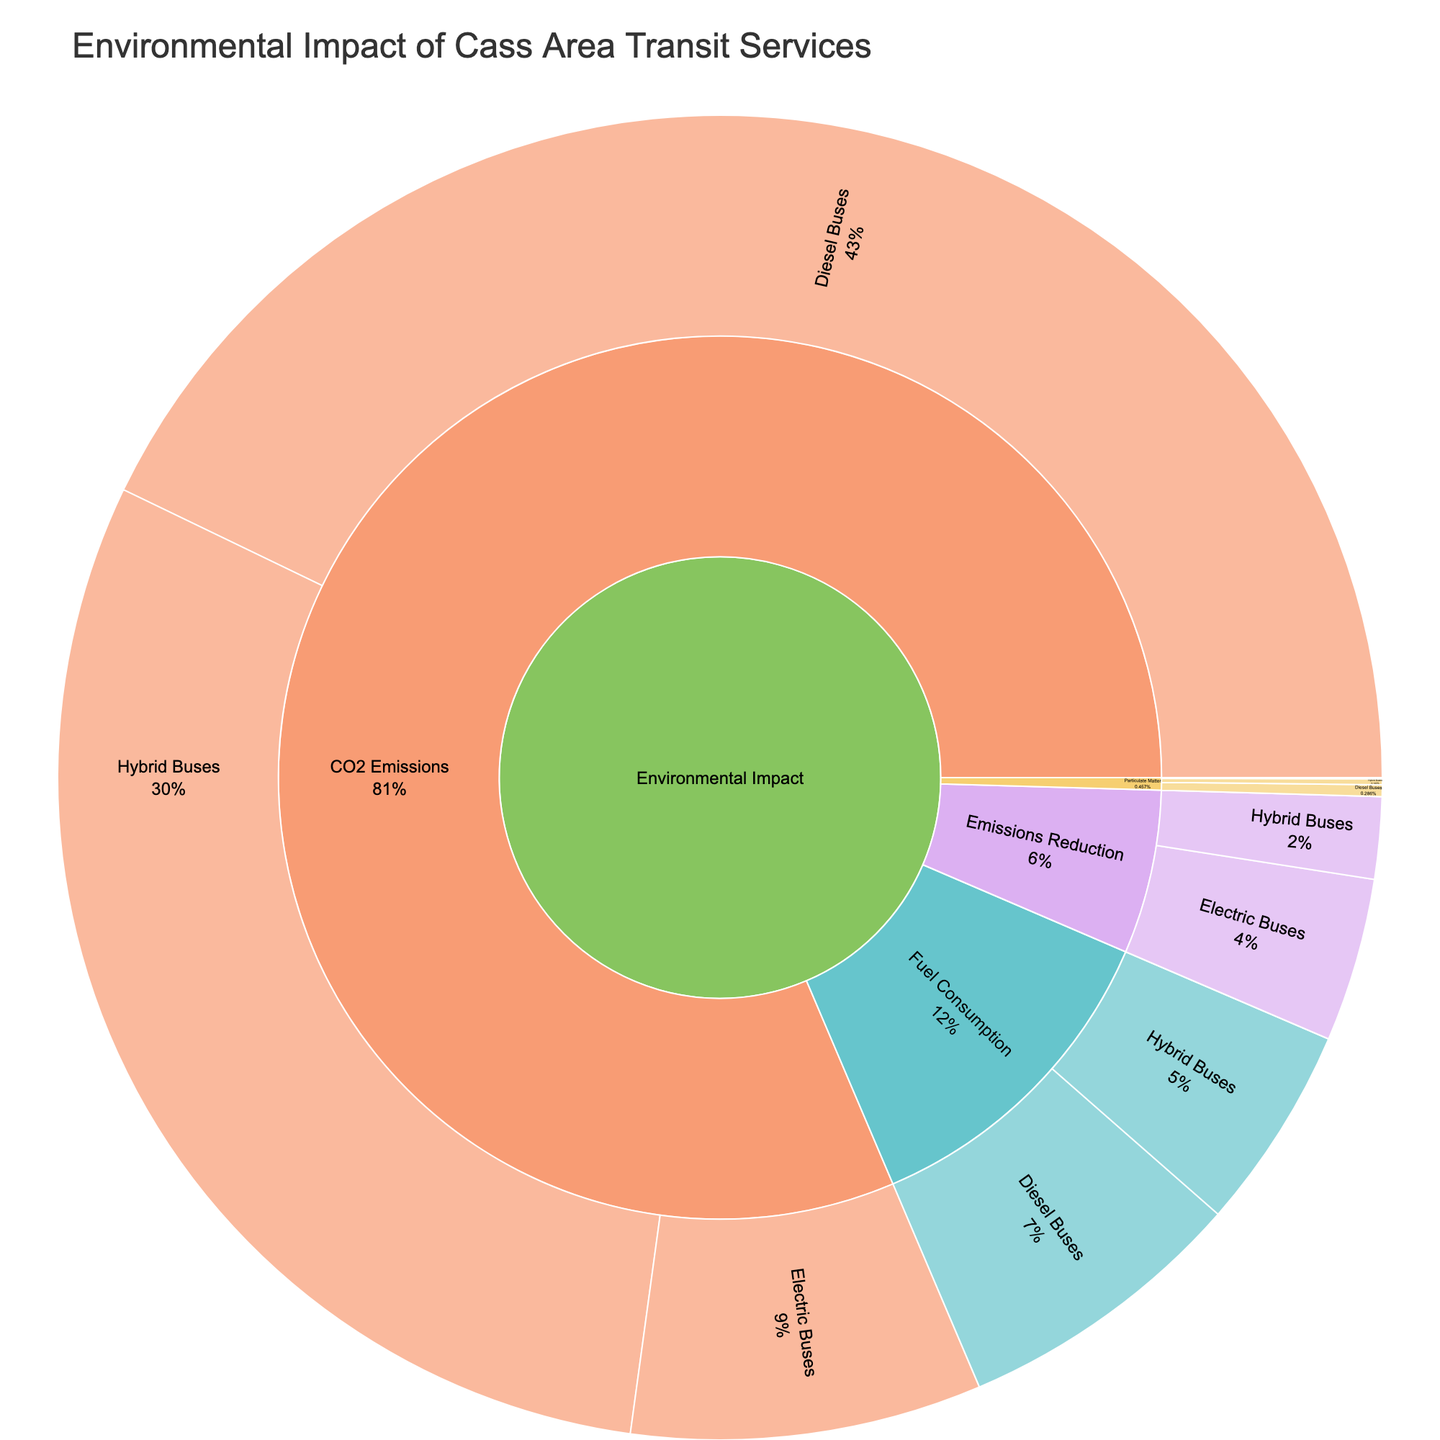What is the title of the Sunburst Plot? The title of the figure is displayed at the top of the plot. It summarizes the main focus or data being visualized.
Answer: Environmental Impact of Cass Area Transit Services What is the fuel consumption value for Electric Buses? The value for Electric Buses under the Fuel Consumption subcategory is displayed in the figure.
Answer: 0 Which vehicle type has the highest CO2 emissions? By looking at the CO2 Emissions subcategory, compare the values for Diesel Buses, Hybrid Buses, and Electric Buses. The highest value corresponds to the vehicle type with the most CO2 emissions.
Answer: Diesel Buses What is the sum of CO2 emissions for Hybrid Buses and Electric Buses? Identify the CO2 Emissions values for Hybrid Buses (52500) and Electric Buses (15000). Add these two values together (52500 + 15000).
Answer: 67500 How much particulate matter do Hybrid Buses produce compared to Diesel Buses? Examine the Particulate Matter subcategory for Hybrid Buses and Diesel Buses. Subtract the value for Hybrid Buses (250) from that of Diesel Buses (500) to find the difference.
Answer: 250 What percentage of the total emissions reduction is contributed by Electric Buses? Find the total emissions reduction by adding the values for Diesel Buses (0), Hybrid Buses (3500), and Electric Buses (7000). Then, calculate the percentage contribution of Electric Buses: (7000 / (0+3500+7000)) * 100%.
Answer: 66.67% Which subcategory only contains values for Diesel Buses and Hybrid Buses but not for Electric Buses? Look through each subcategory (Fuel Consumption, Emissions Reduction, CO2 Emissions, Particulate Matter) to identify if Electric Buses have associated values. One subcategory won't show any value for Electric Buses.
Answer: Fuel Consumption 